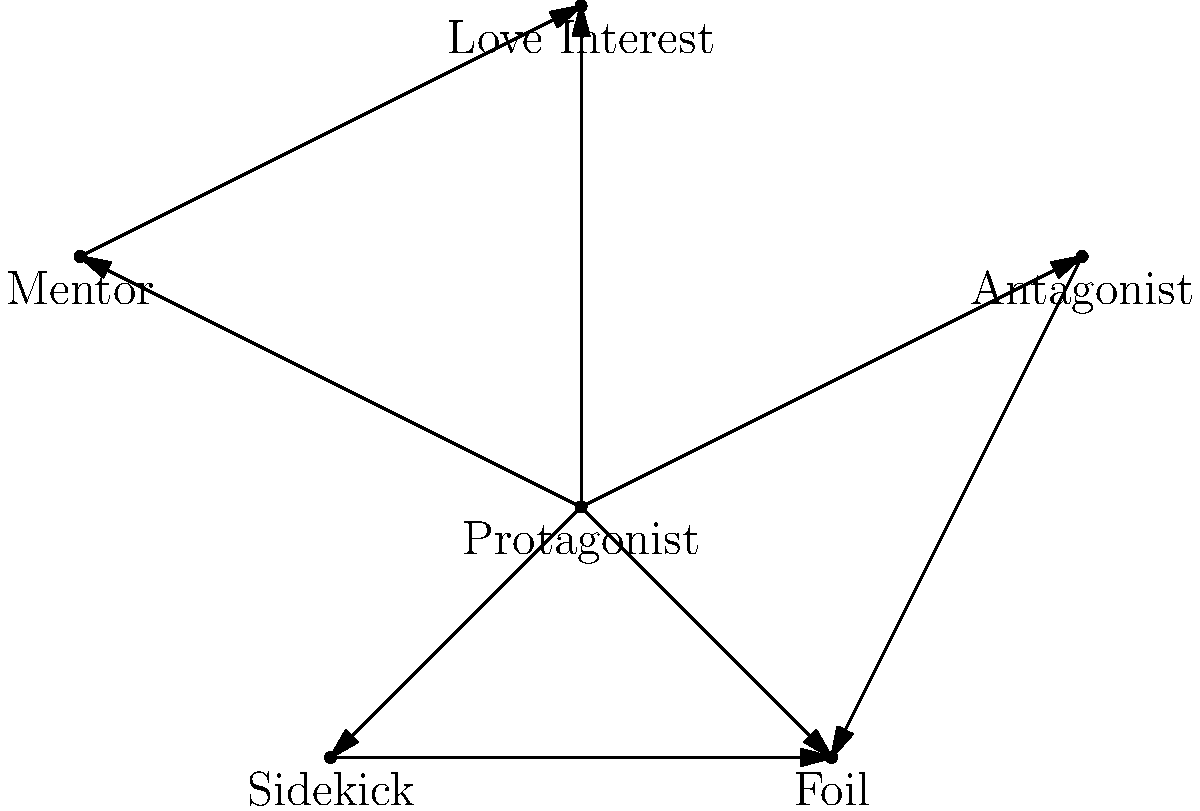In the character relationship web shown above, which character's removal would most significantly alter the psychological complexity of the narrative, and why? Consider the implications on the remaining characters' interactions and development. To answer this question, we need to analyze the role and connections of each character:

1. Protagonist: Central to all relationships, connected to every other character.
2. Antagonist: Direct opposition to the Protagonist, also linked to the Foil.
3. Mentor: Guides the Protagonist, connected to the Love Interest.
4. Love Interest: Emotional core, linked to Protagonist and Mentor.
5. Sidekick: Supports Protagonist, connected to Foil.
6. Foil: Contrasts with Protagonist, linked to Antagonist and Sidekick.

The Mentor's removal would most significantly alter the psychological complexity:

1. It would sever the guidance relationship with the Protagonist, potentially stunting their growth.
2. The connection between Mentor and Love Interest would be lost, removing a layer of complexity in the romantic subplot.
3. Without the Mentor, the Protagonist might struggle more against the Antagonist, intensifying that conflict.
4. The absence of the Mentor could lead to a power vacuum, potentially changing the dynamics between other characters.
5. The loss of the Mentor's wisdom could affect the overall theme and moral compass of the narrative.

This removal would force significant changes in character development, relationships, and overall narrative structure, thereby altering the psychological complexity most profoundly.
Answer: Mentor 